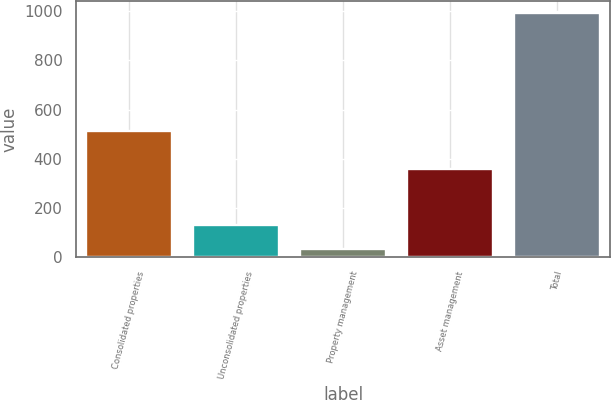<chart> <loc_0><loc_0><loc_500><loc_500><bar_chart><fcel>Consolidated properties<fcel>Unconsolidated properties<fcel>Property management<fcel>Asset management<fcel>Total<nl><fcel>514<fcel>129.8<fcel>34<fcel>359<fcel>992<nl></chart> 